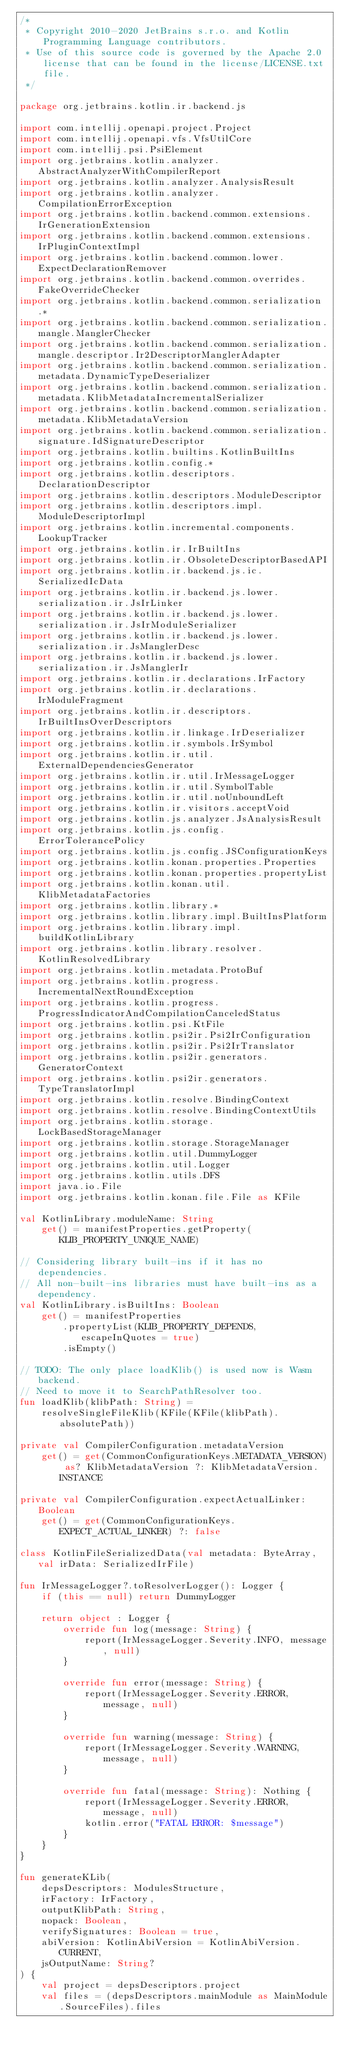Convert code to text. <code><loc_0><loc_0><loc_500><loc_500><_Kotlin_>/*
 * Copyright 2010-2020 JetBrains s.r.o. and Kotlin Programming Language contributors.
 * Use of this source code is governed by the Apache 2.0 license that can be found in the license/LICENSE.txt file.
 */

package org.jetbrains.kotlin.ir.backend.js

import com.intellij.openapi.project.Project
import com.intellij.openapi.vfs.VfsUtilCore
import com.intellij.psi.PsiElement
import org.jetbrains.kotlin.analyzer.AbstractAnalyzerWithCompilerReport
import org.jetbrains.kotlin.analyzer.AnalysisResult
import org.jetbrains.kotlin.analyzer.CompilationErrorException
import org.jetbrains.kotlin.backend.common.extensions.IrGenerationExtension
import org.jetbrains.kotlin.backend.common.extensions.IrPluginContextImpl
import org.jetbrains.kotlin.backend.common.lower.ExpectDeclarationRemover
import org.jetbrains.kotlin.backend.common.overrides.FakeOverrideChecker
import org.jetbrains.kotlin.backend.common.serialization.*
import org.jetbrains.kotlin.backend.common.serialization.mangle.ManglerChecker
import org.jetbrains.kotlin.backend.common.serialization.mangle.descriptor.Ir2DescriptorManglerAdapter
import org.jetbrains.kotlin.backend.common.serialization.metadata.DynamicTypeDeserializer
import org.jetbrains.kotlin.backend.common.serialization.metadata.KlibMetadataIncrementalSerializer
import org.jetbrains.kotlin.backend.common.serialization.metadata.KlibMetadataVersion
import org.jetbrains.kotlin.backend.common.serialization.signature.IdSignatureDescriptor
import org.jetbrains.kotlin.builtins.KotlinBuiltIns
import org.jetbrains.kotlin.config.*
import org.jetbrains.kotlin.descriptors.DeclarationDescriptor
import org.jetbrains.kotlin.descriptors.ModuleDescriptor
import org.jetbrains.kotlin.descriptors.impl.ModuleDescriptorImpl
import org.jetbrains.kotlin.incremental.components.LookupTracker
import org.jetbrains.kotlin.ir.IrBuiltIns
import org.jetbrains.kotlin.ir.ObsoleteDescriptorBasedAPI
import org.jetbrains.kotlin.ir.backend.js.ic.SerializedIcData
import org.jetbrains.kotlin.ir.backend.js.lower.serialization.ir.JsIrLinker
import org.jetbrains.kotlin.ir.backend.js.lower.serialization.ir.JsIrModuleSerializer
import org.jetbrains.kotlin.ir.backend.js.lower.serialization.ir.JsManglerDesc
import org.jetbrains.kotlin.ir.backend.js.lower.serialization.ir.JsManglerIr
import org.jetbrains.kotlin.ir.declarations.IrFactory
import org.jetbrains.kotlin.ir.declarations.IrModuleFragment
import org.jetbrains.kotlin.ir.descriptors.IrBuiltInsOverDescriptors
import org.jetbrains.kotlin.ir.linkage.IrDeserializer
import org.jetbrains.kotlin.ir.symbols.IrSymbol
import org.jetbrains.kotlin.ir.util.ExternalDependenciesGenerator
import org.jetbrains.kotlin.ir.util.IrMessageLogger
import org.jetbrains.kotlin.ir.util.SymbolTable
import org.jetbrains.kotlin.ir.util.noUnboundLeft
import org.jetbrains.kotlin.ir.visitors.acceptVoid
import org.jetbrains.kotlin.js.analyzer.JsAnalysisResult
import org.jetbrains.kotlin.js.config.ErrorTolerancePolicy
import org.jetbrains.kotlin.js.config.JSConfigurationKeys
import org.jetbrains.kotlin.konan.properties.Properties
import org.jetbrains.kotlin.konan.properties.propertyList
import org.jetbrains.kotlin.konan.util.KlibMetadataFactories
import org.jetbrains.kotlin.library.*
import org.jetbrains.kotlin.library.impl.BuiltInsPlatform
import org.jetbrains.kotlin.library.impl.buildKotlinLibrary
import org.jetbrains.kotlin.library.resolver.KotlinResolvedLibrary
import org.jetbrains.kotlin.metadata.ProtoBuf
import org.jetbrains.kotlin.progress.IncrementalNextRoundException
import org.jetbrains.kotlin.progress.ProgressIndicatorAndCompilationCanceledStatus
import org.jetbrains.kotlin.psi.KtFile
import org.jetbrains.kotlin.psi2ir.Psi2IrConfiguration
import org.jetbrains.kotlin.psi2ir.Psi2IrTranslator
import org.jetbrains.kotlin.psi2ir.generators.GeneratorContext
import org.jetbrains.kotlin.psi2ir.generators.TypeTranslatorImpl
import org.jetbrains.kotlin.resolve.BindingContext
import org.jetbrains.kotlin.resolve.BindingContextUtils
import org.jetbrains.kotlin.storage.LockBasedStorageManager
import org.jetbrains.kotlin.storage.StorageManager
import org.jetbrains.kotlin.util.DummyLogger
import org.jetbrains.kotlin.util.Logger
import org.jetbrains.kotlin.utils.DFS
import java.io.File
import org.jetbrains.kotlin.konan.file.File as KFile

val KotlinLibrary.moduleName: String
    get() = manifestProperties.getProperty(KLIB_PROPERTY_UNIQUE_NAME)

// Considering library built-ins if it has no dependencies.
// All non-built-ins libraries must have built-ins as a dependency.
val KotlinLibrary.isBuiltIns: Boolean
    get() = manifestProperties
        .propertyList(KLIB_PROPERTY_DEPENDS, escapeInQuotes = true)
        .isEmpty()

// TODO: The only place loadKlib() is used now is Wasm backend.
// Need to move it to SearchPathResolver too.
fun loadKlib(klibPath: String) =
    resolveSingleFileKlib(KFile(KFile(klibPath).absolutePath))

private val CompilerConfiguration.metadataVersion
    get() = get(CommonConfigurationKeys.METADATA_VERSION) as? KlibMetadataVersion ?: KlibMetadataVersion.INSTANCE

private val CompilerConfiguration.expectActualLinker: Boolean
    get() = get(CommonConfigurationKeys.EXPECT_ACTUAL_LINKER) ?: false

class KotlinFileSerializedData(val metadata: ByteArray, val irData: SerializedIrFile)

fun IrMessageLogger?.toResolverLogger(): Logger {
    if (this == null) return DummyLogger

    return object : Logger {
        override fun log(message: String) {
            report(IrMessageLogger.Severity.INFO, message, null)
        }

        override fun error(message: String) {
            report(IrMessageLogger.Severity.ERROR, message, null)
        }

        override fun warning(message: String) {
            report(IrMessageLogger.Severity.WARNING, message, null)
        }

        override fun fatal(message: String): Nothing {
            report(IrMessageLogger.Severity.ERROR, message, null)
            kotlin.error("FATAL ERROR: $message")
        }
    }
}

fun generateKLib(
    depsDescriptors: ModulesStructure,
    irFactory: IrFactory,
    outputKlibPath: String,
    nopack: Boolean,
    verifySignatures: Boolean = true,
    abiVersion: KotlinAbiVersion = KotlinAbiVersion.CURRENT,
    jsOutputName: String?
) {
    val project = depsDescriptors.project
    val files = (depsDescriptors.mainModule as MainModule.SourceFiles).files</code> 